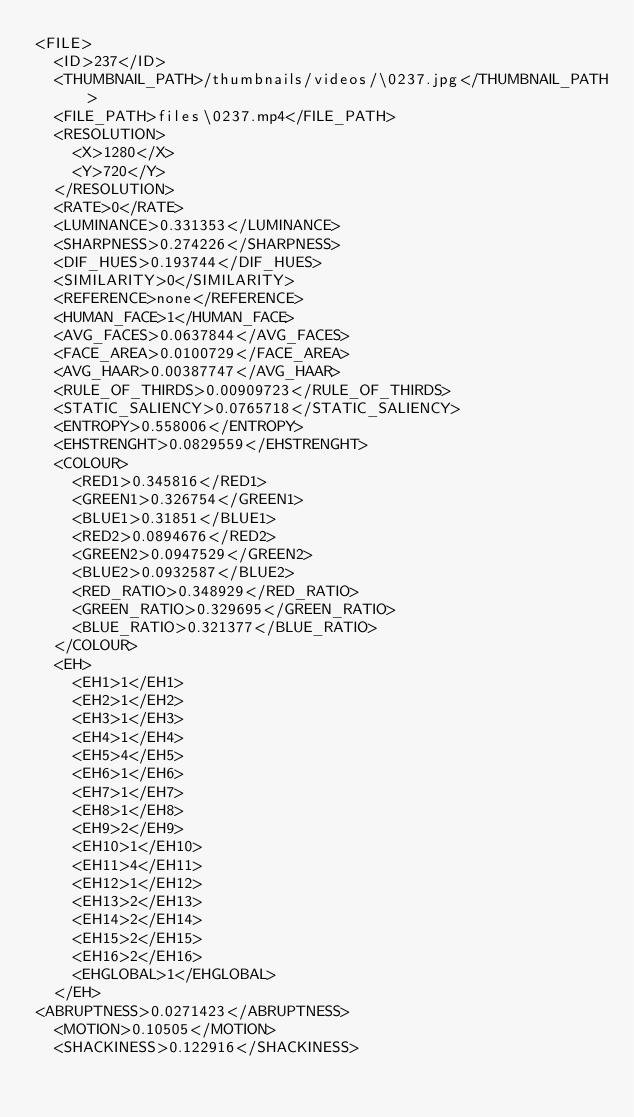Convert code to text. <code><loc_0><loc_0><loc_500><loc_500><_XML_><FILE>
	<ID>237</ID>
	<THUMBNAIL_PATH>/thumbnails/videos/\0237.jpg</THUMBNAIL_PATH>
	<FILE_PATH>files\0237.mp4</FILE_PATH>
	<RESOLUTION>
		<X>1280</X>
		<Y>720</Y>
	</RESOLUTION>
	<RATE>0</RATE>
	<LUMINANCE>0.331353</LUMINANCE>
	<SHARPNESS>0.274226</SHARPNESS>
	<DIF_HUES>0.193744</DIF_HUES>
	<SIMILARITY>0</SIMILARITY>
	<REFERENCE>none</REFERENCE>
	<HUMAN_FACE>1</HUMAN_FACE>
	<AVG_FACES>0.0637844</AVG_FACES>
	<FACE_AREA>0.0100729</FACE_AREA>
	<AVG_HAAR>0.00387747</AVG_HAAR>
	<RULE_OF_THIRDS>0.00909723</RULE_OF_THIRDS>
	<STATIC_SALIENCY>0.0765718</STATIC_SALIENCY>
	<ENTROPY>0.558006</ENTROPY>
	<EHSTRENGHT>0.0829559</EHSTRENGHT>
	<COLOUR>
		<RED1>0.345816</RED1>
		<GREEN1>0.326754</GREEN1>
		<BLUE1>0.31851</BLUE1>
		<RED2>0.0894676</RED2>
		<GREEN2>0.0947529</GREEN2>
		<BLUE2>0.0932587</BLUE2>
		<RED_RATIO>0.348929</RED_RATIO>
		<GREEN_RATIO>0.329695</GREEN_RATIO>
		<BLUE_RATIO>0.321377</BLUE_RATIO>
	</COLOUR>
	<EH>
		<EH1>1</EH1>
		<EH2>1</EH2>
		<EH3>1</EH3>
		<EH4>1</EH4>
		<EH5>4</EH5>
		<EH6>1</EH6>
		<EH7>1</EH7>
		<EH8>1</EH8>
		<EH9>2</EH9>
		<EH10>1</EH10>
		<EH11>4</EH11>
		<EH12>1</EH12>
		<EH13>2</EH13>
		<EH14>2</EH14>
		<EH15>2</EH15>
		<EH16>2</EH16>
		<EHGLOBAL>1</EHGLOBAL>
	</EH>
<ABRUPTNESS>0.0271423</ABRUPTNESS>
	<MOTION>0.10505</MOTION>
	<SHACKINESS>0.122916</SHACKINESS></code> 